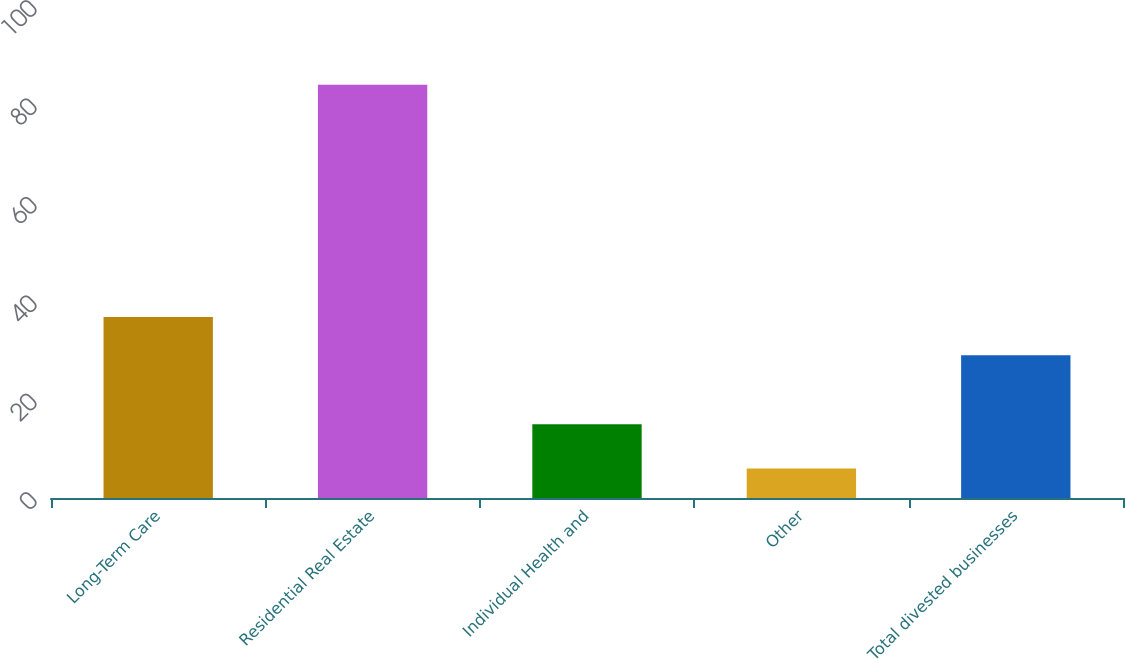Convert chart to OTSL. <chart><loc_0><loc_0><loc_500><loc_500><bar_chart><fcel>Long-Term Care<fcel>Residential Real Estate<fcel>Individual Health and<fcel>Other<fcel>Total divested businesses<nl><fcel>36.8<fcel>84<fcel>15<fcel>6<fcel>29<nl></chart> 